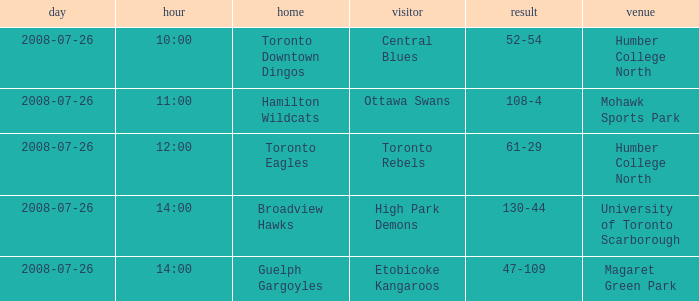With the Ground of Humber College North at 12:00, what was the Away? Toronto Rebels. 